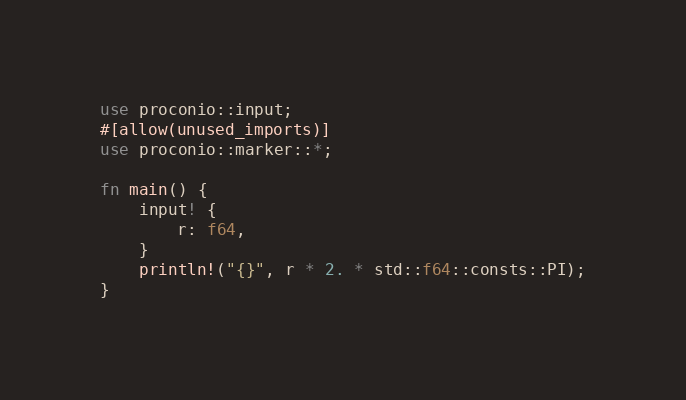Convert code to text. <code><loc_0><loc_0><loc_500><loc_500><_Rust_>use proconio::input;
#[allow(unused_imports)]
use proconio::marker::*;

fn main() {
    input! {
        r: f64,
    }
    println!("{}", r * 2. * std::f64::consts::PI);
}
</code> 